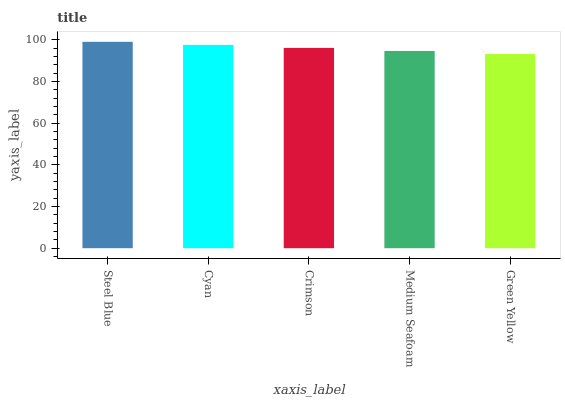Is Green Yellow the minimum?
Answer yes or no. Yes. Is Steel Blue the maximum?
Answer yes or no. Yes. Is Cyan the minimum?
Answer yes or no. No. Is Cyan the maximum?
Answer yes or no. No. Is Steel Blue greater than Cyan?
Answer yes or no. Yes. Is Cyan less than Steel Blue?
Answer yes or no. Yes. Is Cyan greater than Steel Blue?
Answer yes or no. No. Is Steel Blue less than Cyan?
Answer yes or no. No. Is Crimson the high median?
Answer yes or no. Yes. Is Crimson the low median?
Answer yes or no. Yes. Is Cyan the high median?
Answer yes or no. No. Is Medium Seafoam the low median?
Answer yes or no. No. 